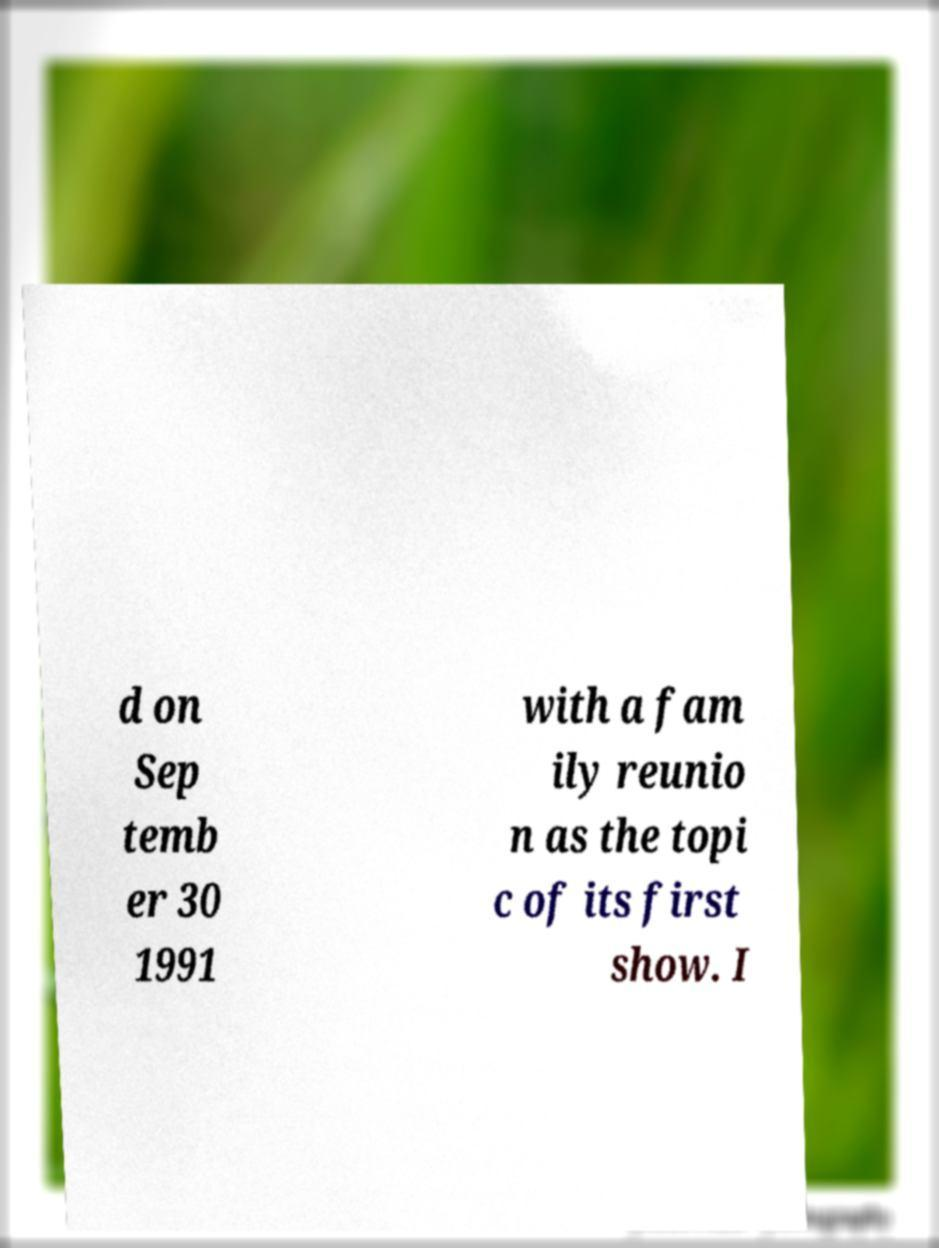What messages or text are displayed in this image? I need them in a readable, typed format. d on Sep temb er 30 1991 with a fam ily reunio n as the topi c of its first show. I 